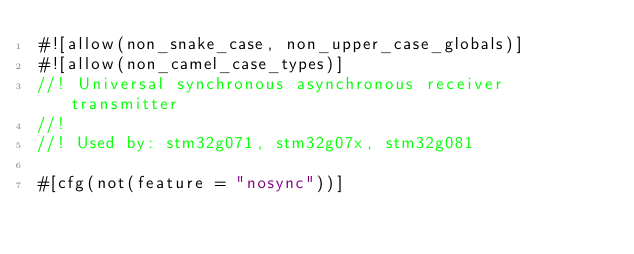Convert code to text. <code><loc_0><loc_0><loc_500><loc_500><_Rust_>#![allow(non_snake_case, non_upper_case_globals)]
#![allow(non_camel_case_types)]
//! Universal synchronous asynchronous receiver transmitter
//!
//! Used by: stm32g071, stm32g07x, stm32g081

#[cfg(not(feature = "nosync"))]</code> 